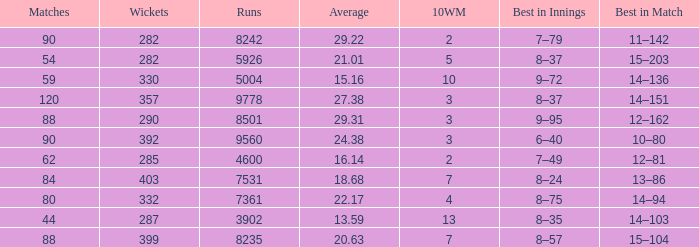What is the total number of wickets that have runs under 4600 and matches under 44? None. 